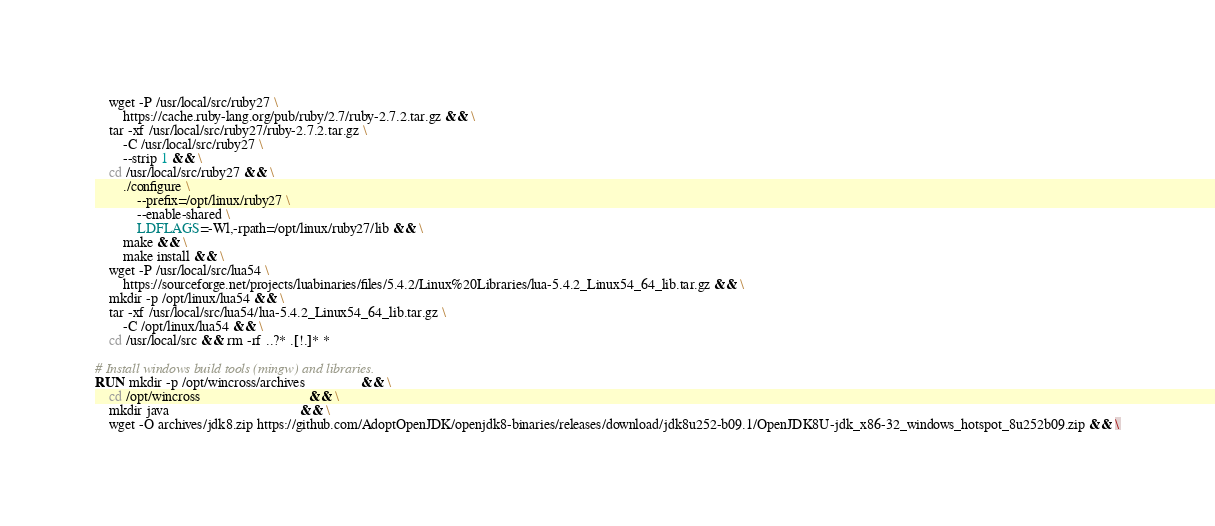<code> <loc_0><loc_0><loc_500><loc_500><_Dockerfile_>    wget -P /usr/local/src/ruby27 \
        https://cache.ruby-lang.org/pub/ruby/2.7/ruby-2.7.2.tar.gz && \
    tar -xf /usr/local/src/ruby27/ruby-2.7.2.tar.gz \
        -C /usr/local/src/ruby27 \
        --strip 1 && \
    cd /usr/local/src/ruby27 && \
        ./configure \
            --prefix=/opt/linux/ruby27 \
            --enable-shared \
            LDFLAGS=-Wl,-rpath=/opt/linux/ruby27/lib && \
        make && \
        make install && \
    wget -P /usr/local/src/lua54 \
        https://sourceforge.net/projects/luabinaries/files/5.4.2/Linux%20Libraries/lua-5.4.2_Linux54_64_lib.tar.gz && \
    mkdir -p /opt/linux/lua54 && \
    tar -xf /usr/local/src/lua54/lua-5.4.2_Linux54_64_lib.tar.gz \
        -C /opt/linux/lua54 && \
    cd /usr/local/src && rm -rf ..?* .[!.]* *

# Install windows build tools (mingw) and libraries.
RUN mkdir -p /opt/wincross/archives                && \
    cd /opt/wincross                               && \
    mkdir java                                     && \
    wget -O archives/jdk8.zip https://github.com/AdoptOpenJDK/openjdk8-binaries/releases/download/jdk8u252-b09.1/OpenJDK8U-jdk_x86-32_windows_hotspot_8u252b09.zip && \</code> 